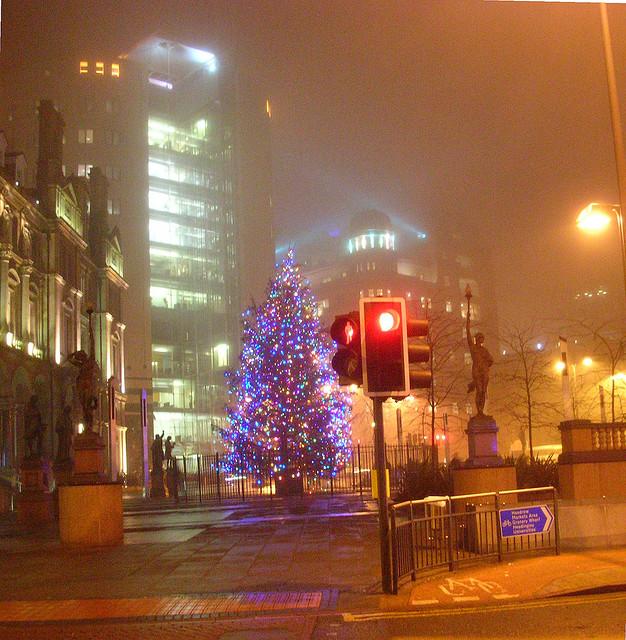What is the speed limit?
Write a very short answer. 0. Is it snowing?
Short answer required. No. What color is the tree?
Short answer required. Green. What color is the traffic light?
Short answer required. Red. 